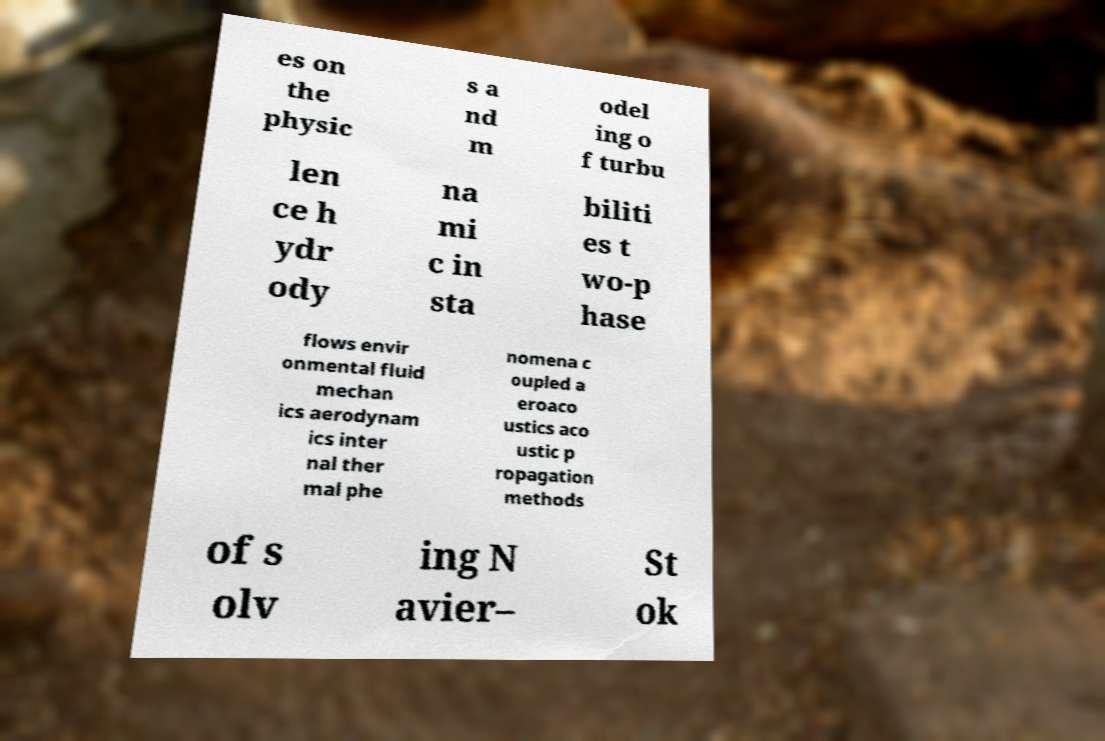Could you extract and type out the text from this image? es on the physic s a nd m odel ing o f turbu len ce h ydr ody na mi c in sta biliti es t wo-p hase flows envir onmental fluid mechan ics aerodynam ics inter nal ther mal phe nomena c oupled a eroaco ustics aco ustic p ropagation methods of s olv ing N avier– St ok 